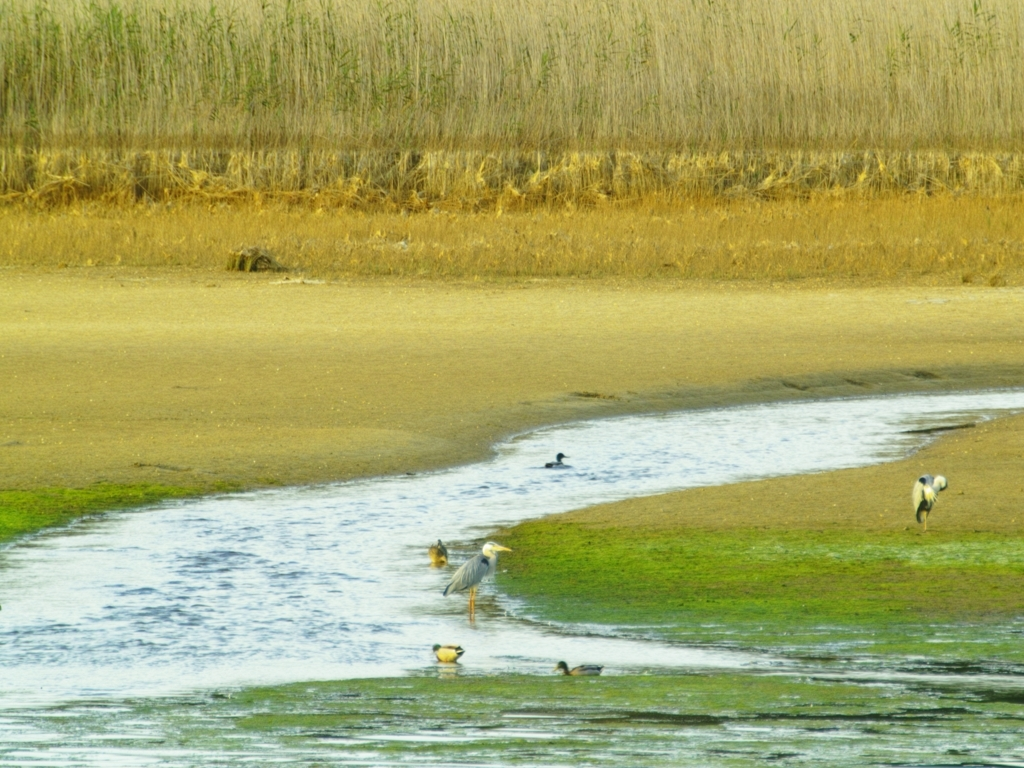Could you inform me about the types of birds visible in this image? The image showcases a variety of birds that are likely adapted to wetland environments. Given the distance and angle, identifying specific species is challenging, but we can see a heron-like bird, which could be looking for fish in the shallow water, and several smaller birds that might be waders or shorebirds. 